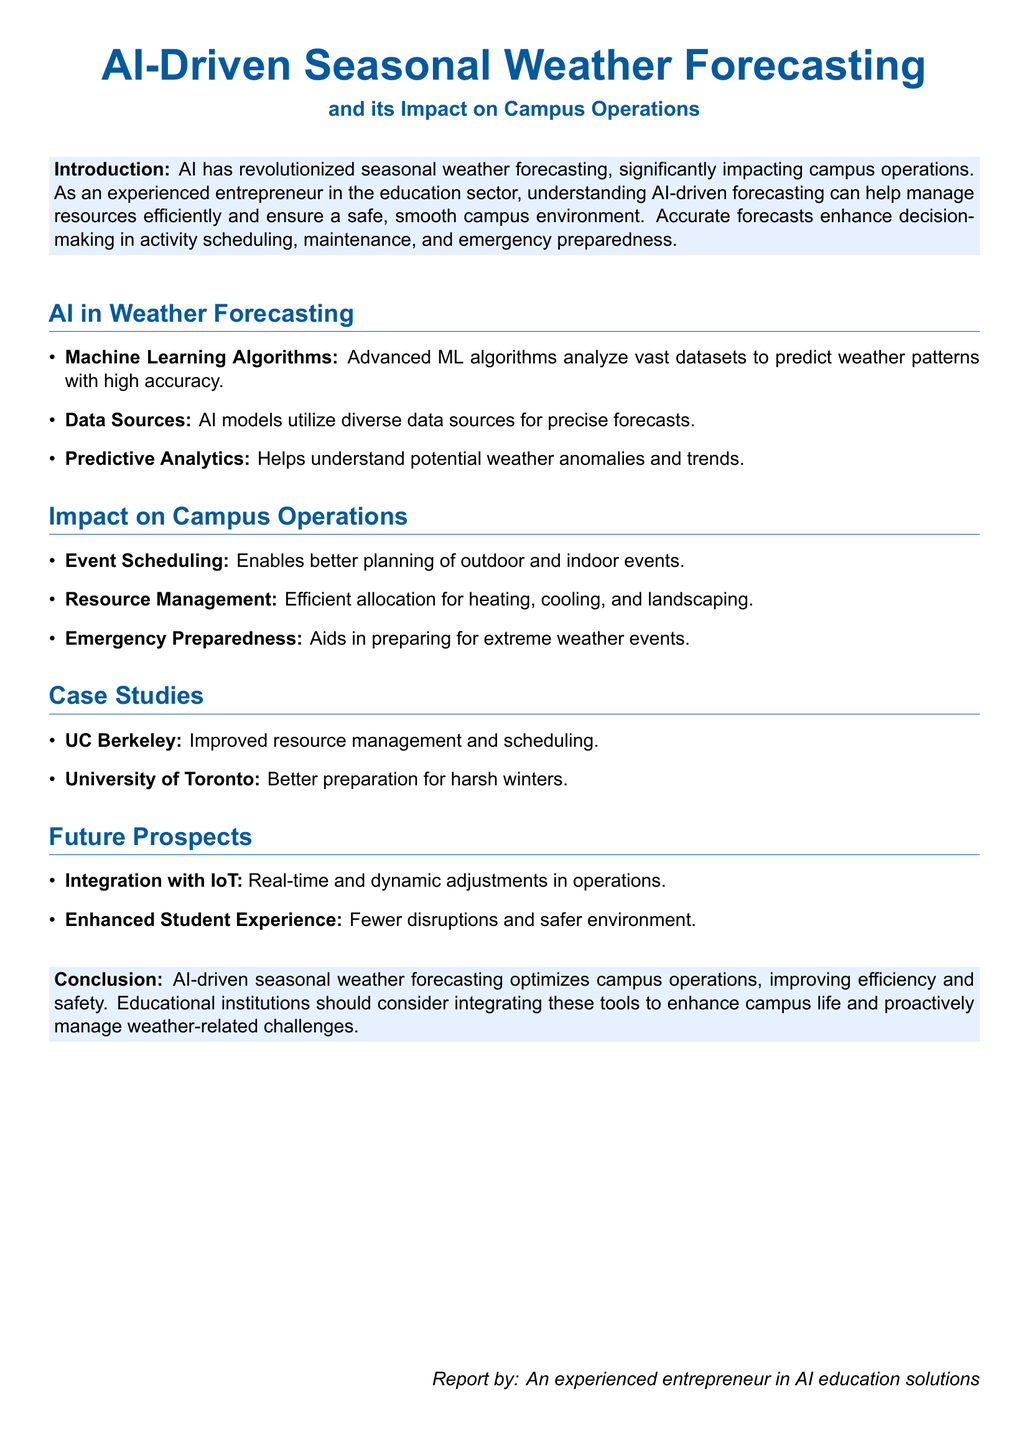What is the title of the report? The title of the report is stated at the beginning and is "AI-Driven Seasonal Weather Forecasting and its Impact on Campus Operations."
Answer: AI-Driven Seasonal Weather Forecasting and its Impact on Campus Operations What technology is used to analyze weather data? The document specifies that advanced machine learning algorithms are used for data analysis.
Answer: Machine Learning Algorithms Which university is mentioned as a case study? The document lists UC Berkeley and the University of Toronto as case studies in the impact of AI on campus operations.
Answer: UC Berkeley What is one of the benefits of AI forecasting mentioned? The report states that accurate forecasts enhance decision-making, which is a key benefit of AI forecasting.
Answer: Enhanced decision-making How does AI aid in emergency preparedness? The document states that AI helps in preparing for extreme weather events, which is related to emergency preparedness.
Answer: Preparing for extreme weather events What are future prospects of AI in campus operations? The document mentions integration with IoT as one of the prospects for future applications of AI in campus operations.
Answer: Integration with IoT What does the conclusion suggest about AI-driven forecasting? The conclusion mentions that AI-driven seasonal weather forecasting optimizes campus operations, indicating its overall impact.
Answer: Optimizes campus operations How does AI affect student experience according to the report? The document specifies that AI contributes to fewer disruptions and a safer environment for students.
Answer: Fewer disruptions and safer environment 